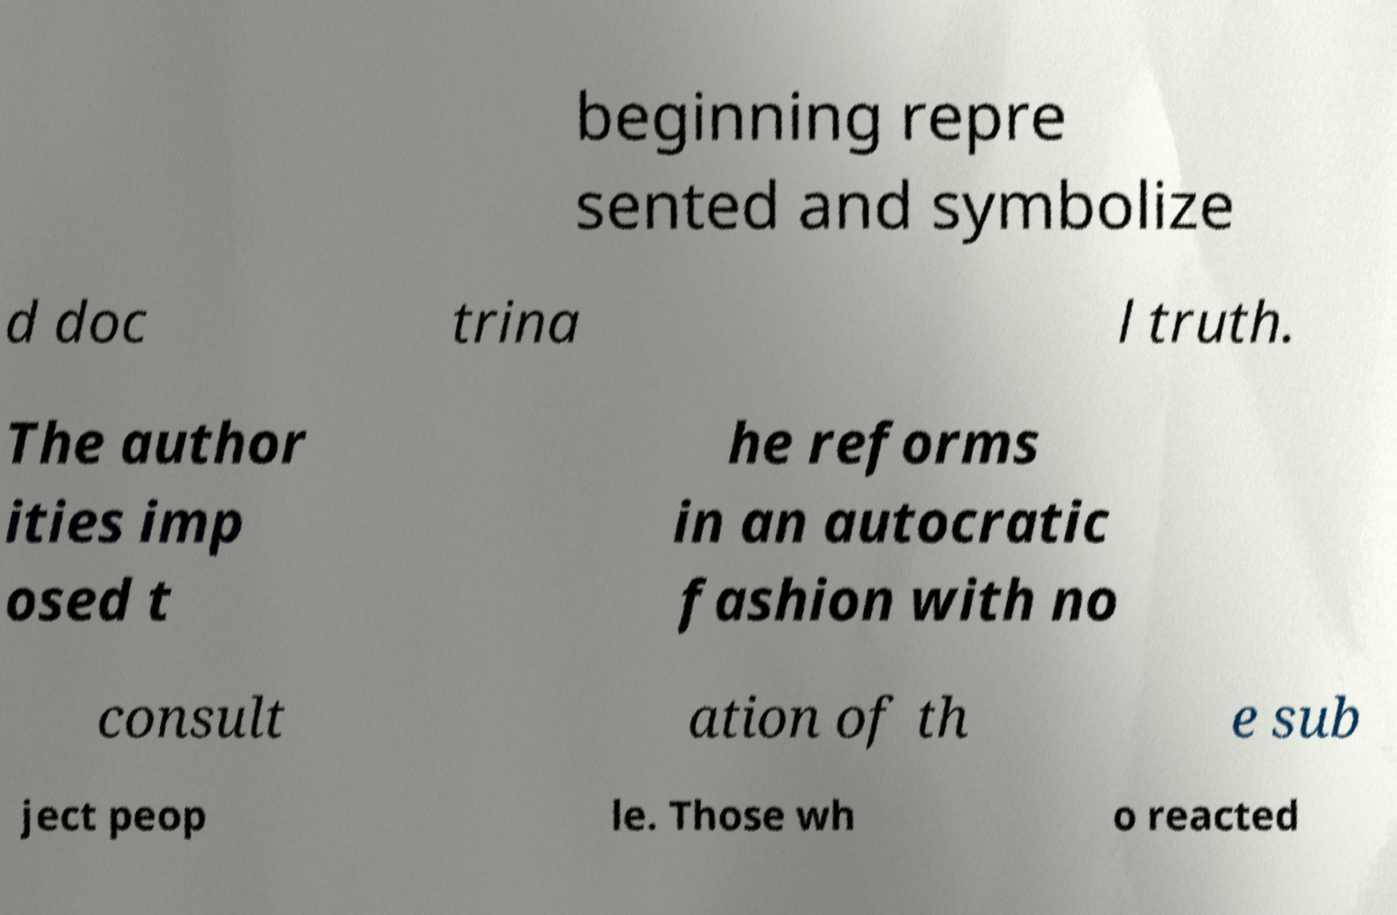Please identify and transcribe the text found in this image. beginning repre sented and symbolize d doc trina l truth. The author ities imp osed t he reforms in an autocratic fashion with no consult ation of th e sub ject peop le. Those wh o reacted 